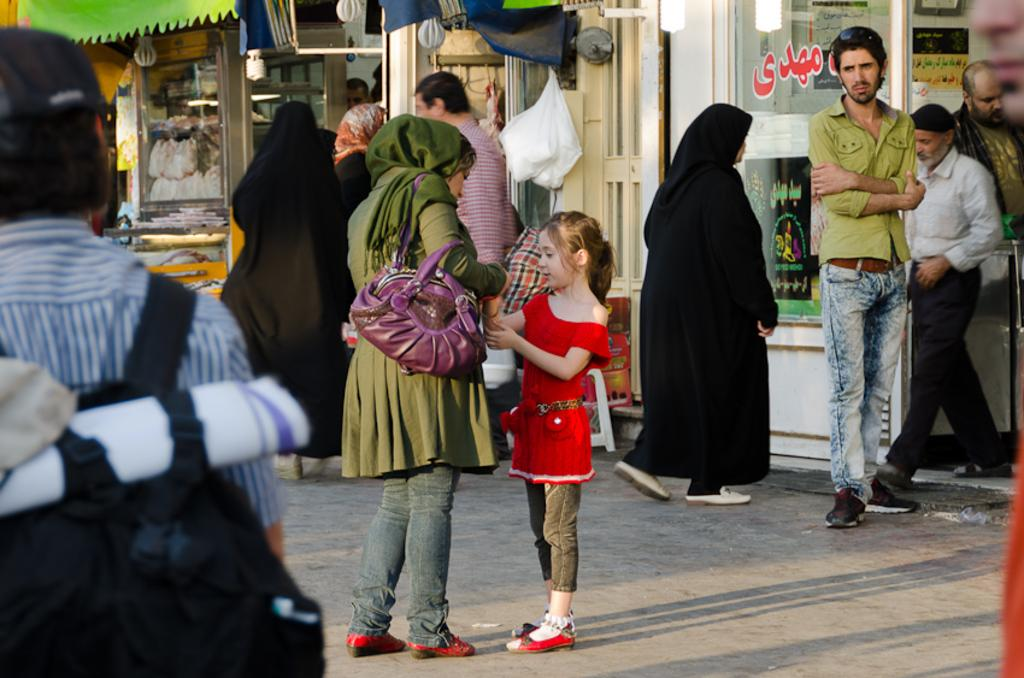What is the main subject of the image? The main subject of the image is a crowd of people. Where is the crowd located in the image? The crowd is in front of a building. What else can be seen on the building in the image? There is a carry bag attached to the wall of the building. How many ducks are visible in the image? There are no ducks present in the image. What type of disease is being treated in the image? There is no indication of any disease or medical treatment in the image. 